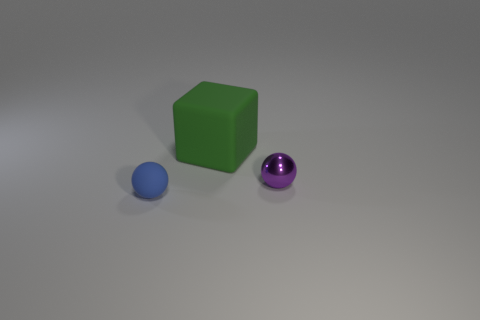Is there any other thing that is the same size as the green thing?
Your answer should be very brief. No. What number of purple objects are either small things or large matte cubes?
Ensure brevity in your answer.  1. What number of things are the same size as the matte sphere?
Your answer should be very brief. 1. Is the material of the thing in front of the small purple metal object the same as the big green block?
Your answer should be compact. Yes. There is a small shiny sphere on the right side of the large green rubber thing; is there a tiny matte sphere that is left of it?
Keep it short and to the point. Yes. There is another tiny thing that is the same shape as the blue rubber thing; what material is it?
Offer a terse response. Metal. Is the number of small purple objects that are behind the blue object greater than the number of objects that are behind the cube?
Give a very brief answer. Yes. There is a big green thing that is the same material as the blue ball; what is its shape?
Provide a succinct answer. Cube. Are there more big green matte things behind the blue rubber sphere than big yellow rubber things?
Offer a terse response. Yes. How many other large blocks are the same color as the large matte block?
Make the answer very short. 0. 